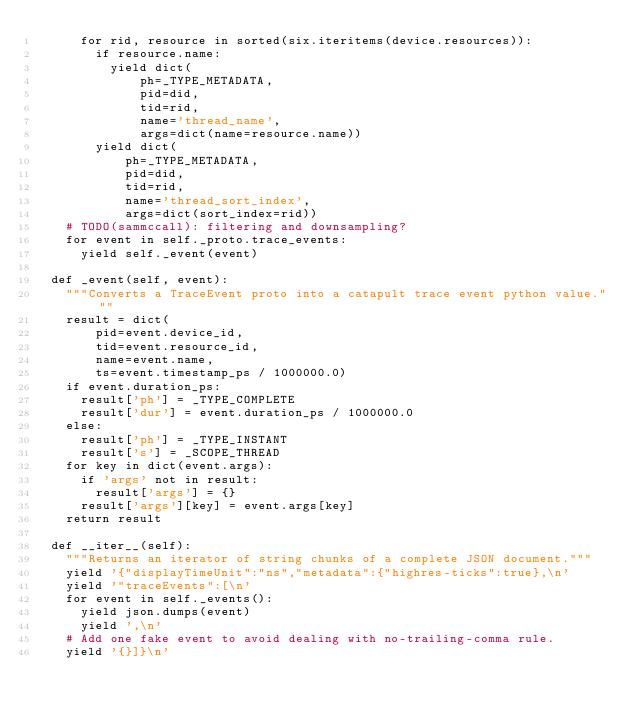Convert code to text. <code><loc_0><loc_0><loc_500><loc_500><_Python_>      for rid, resource in sorted(six.iteritems(device.resources)):
        if resource.name:
          yield dict(
              ph=_TYPE_METADATA,
              pid=did,
              tid=rid,
              name='thread_name',
              args=dict(name=resource.name))
        yield dict(
            ph=_TYPE_METADATA,
            pid=did,
            tid=rid,
            name='thread_sort_index',
            args=dict(sort_index=rid))
    # TODO(sammccall): filtering and downsampling?
    for event in self._proto.trace_events:
      yield self._event(event)

  def _event(self, event):
    """Converts a TraceEvent proto into a catapult trace event python value."""
    result = dict(
        pid=event.device_id,
        tid=event.resource_id,
        name=event.name,
        ts=event.timestamp_ps / 1000000.0)
    if event.duration_ps:
      result['ph'] = _TYPE_COMPLETE
      result['dur'] = event.duration_ps / 1000000.0
    else:
      result['ph'] = _TYPE_INSTANT
      result['s'] = _SCOPE_THREAD
    for key in dict(event.args):
      if 'args' not in result:
        result['args'] = {}
      result['args'][key] = event.args[key]
    return result

  def __iter__(self):
    """Returns an iterator of string chunks of a complete JSON document."""
    yield '{"displayTimeUnit":"ns","metadata":{"highres-ticks":true},\n'
    yield '"traceEvents":[\n'
    for event in self._events():
      yield json.dumps(event)
      yield ',\n'
    # Add one fake event to avoid dealing with no-trailing-comma rule.
    yield '{}]}\n'
</code> 